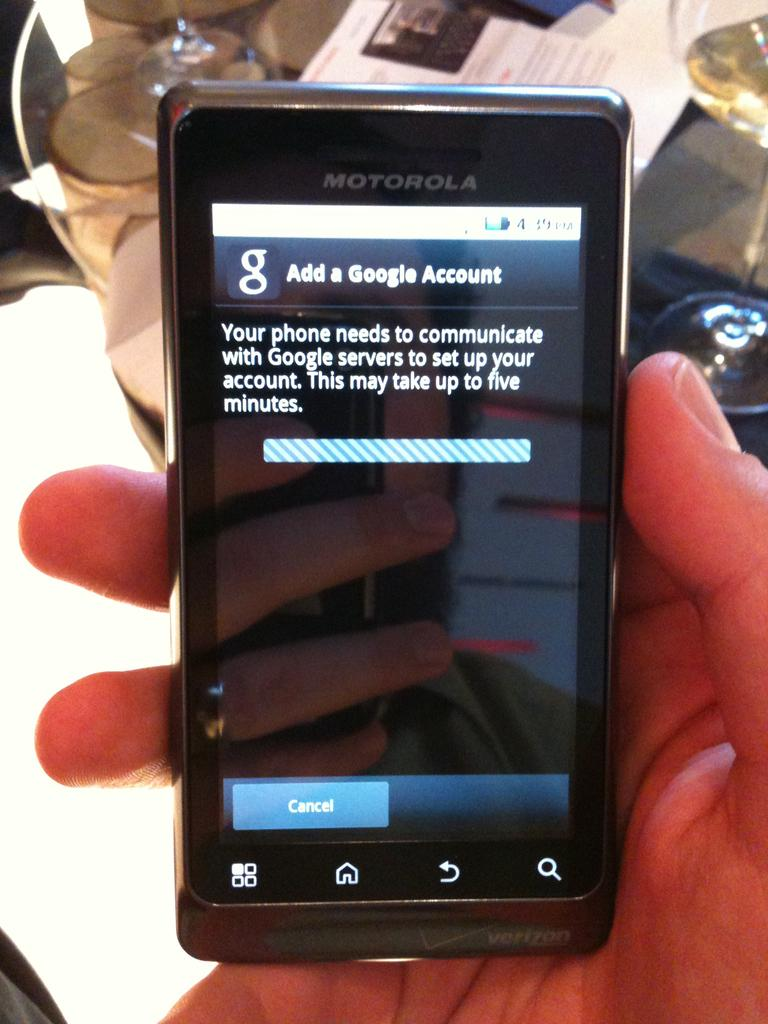<image>
Give a short and clear explanation of the subsequent image. a hand holding a cell phone that has add a google account on the screen 